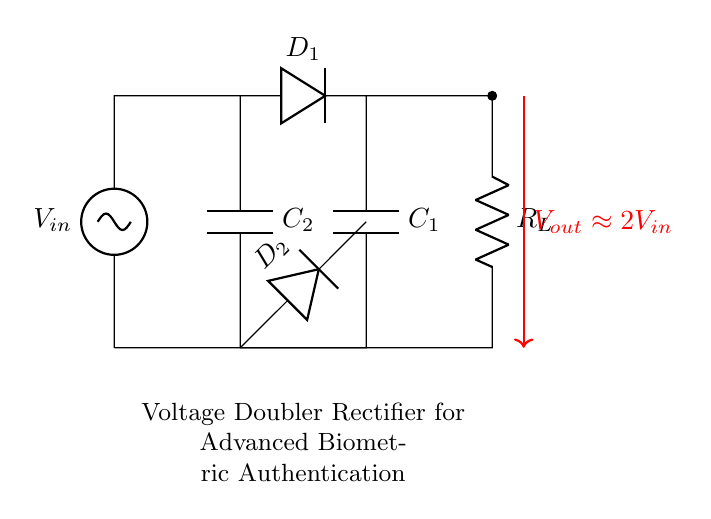What is the input voltage in the circuit? The input voltage is indicated as V_in, which represents the supply voltage provided to the rectifier.
Answer: V_in What type of diodes are used in this circuit? The circuit diagram includes two diodes, labeled D_1 and D_2, which are the key components for rectification.
Answer: Diodes What is the purpose of capacitors C_1 and C_2? Capacitors C_1 and C_2 are used to store electrical charge and smooth out fluctuations in voltage, serving as filtering components in the circuit.
Answer: Energy storage What is the output voltage of the voltage doubler circuit? The output voltage is approximately double the input voltage, as indicated by the label V_out, which is expressed as 2V_in in the circuit.
Answer: 2V_in How many loads can be powered by this circuit? The circuit shows a single load connected (R_L), implying that it is designed to power one load at a time.
Answer: One load What happens to the voltage across the load when the circuit operates? The voltage across the load R_L increases to nearly double the input voltage, indicating effective voltage doubling by the design of the circuit.
Answer: Approximates 2V_in What is the role of resistor R_L in this configuration? Resistor R_L serves as the load in the circuit, absorbing power from the output voltage produced by the rectifier.
Answer: Load 